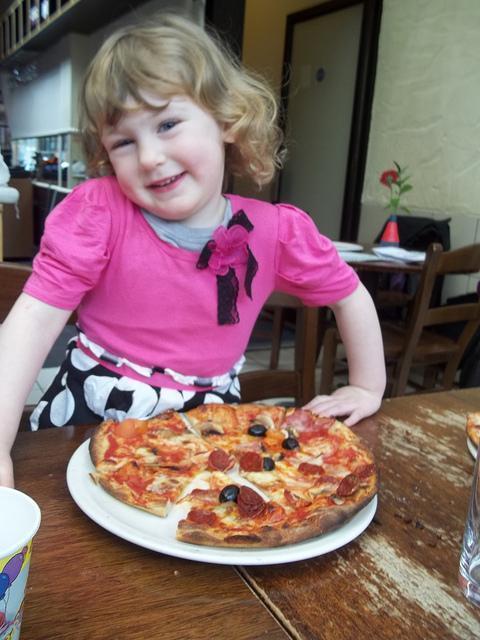How many pizza?
Give a very brief answer. 1. How many cups are visible?
Give a very brief answer. 2. How many chairs are there?
Give a very brief answer. 2. 